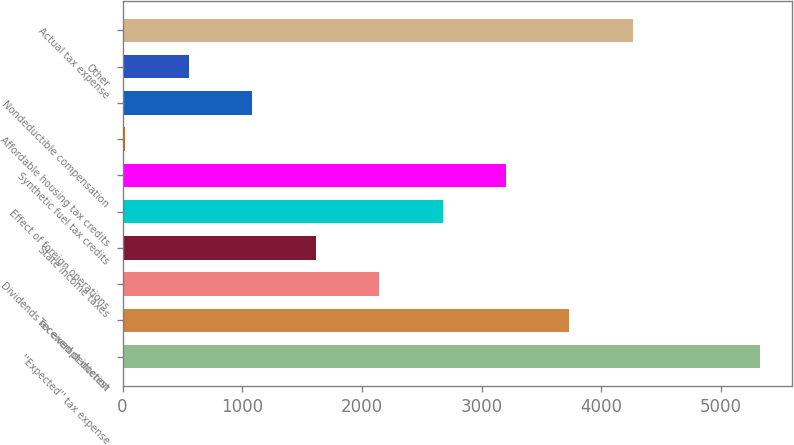Convert chart to OTSL. <chart><loc_0><loc_0><loc_500><loc_500><bar_chart><fcel>''Expected'' tax expense<fcel>Tax exempt interest<fcel>Dividends received deduction<fcel>State income taxes<fcel>Effect of foreign operations<fcel>Synthetic fuel tax credits<fcel>Affordable housing tax credits<fcel>Nondeductible compensation<fcel>Other<fcel>Actual tax expense<nl><fcel>5325<fcel>3734.1<fcel>2143.2<fcel>1612.9<fcel>2673.5<fcel>3203.8<fcel>22<fcel>1082.6<fcel>552.3<fcel>4264.4<nl></chart> 